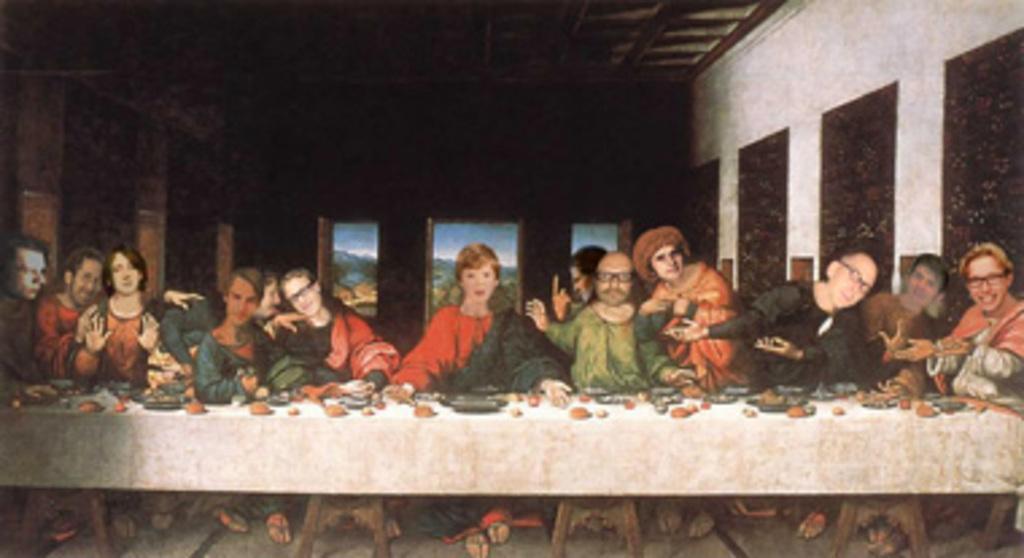Could you give a brief overview of what you see in this image? In this image I can see group of people sitting, in front of them I can see a table, at right I can see the wall in white color. 